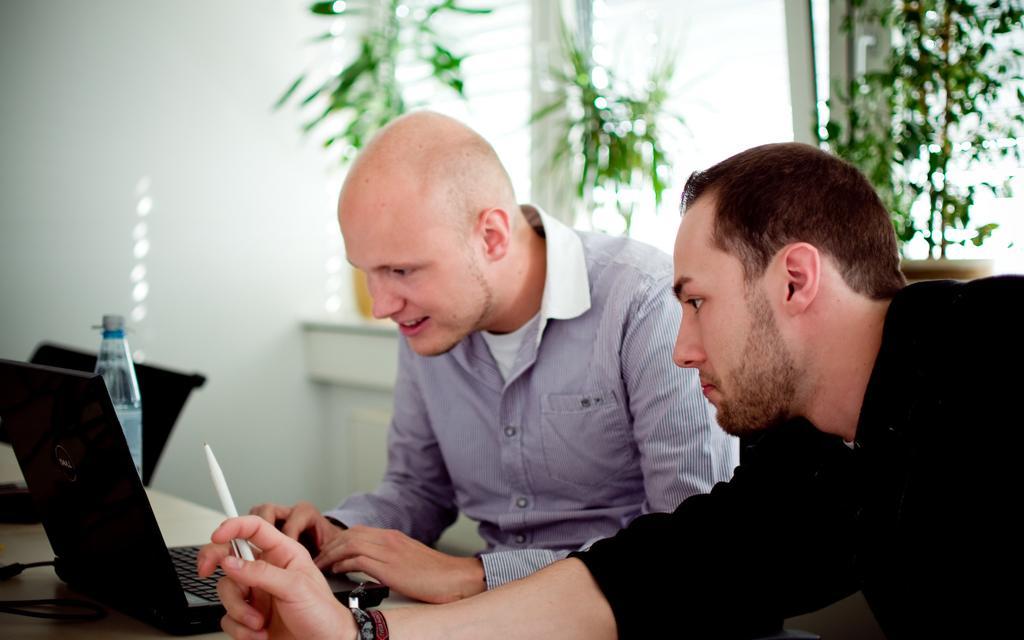Could you give a brief overview of what you see in this image? In this picture, we can see two persons, and we can see a laptop, wires bottles on the desk and we can see the wall with windows and we can see some plants and chairs. 